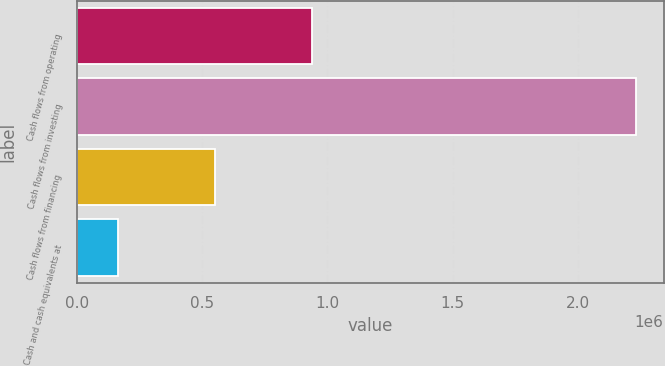Convert chart. <chart><loc_0><loc_0><loc_500><loc_500><bar_chart><fcel>Cash flows from operating<fcel>Cash flows from investing<fcel>Cash flows from financing<fcel>Cash and cash equivalents at<nl><fcel>936544<fcel>2.23013e+06<fcel>550678<fcel>165485<nl></chart> 